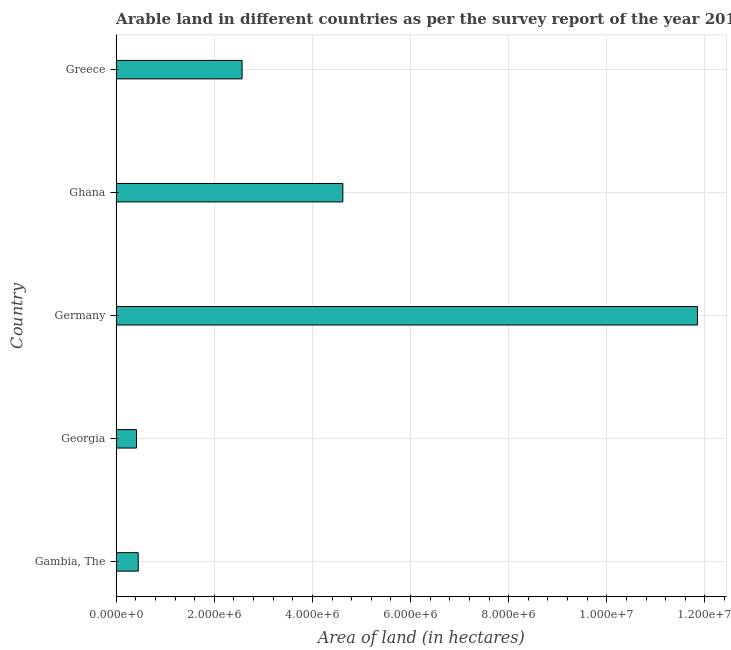Does the graph contain any zero values?
Make the answer very short. No. Does the graph contain grids?
Offer a very short reply. Yes. What is the title of the graph?
Offer a very short reply. Arable land in different countries as per the survey report of the year 2010. What is the label or title of the X-axis?
Provide a succinct answer. Area of land (in hectares). What is the label or title of the Y-axis?
Provide a short and direct response. Country. What is the area of land in Georgia?
Your answer should be very brief. 4.15e+05. Across all countries, what is the maximum area of land?
Offer a terse response. 1.18e+07. Across all countries, what is the minimum area of land?
Give a very brief answer. 4.15e+05. In which country was the area of land maximum?
Offer a terse response. Germany. In which country was the area of land minimum?
Keep it short and to the point. Georgia. What is the sum of the area of land?
Give a very brief answer. 1.99e+07. What is the difference between the area of land in Germany and Greece?
Your answer should be very brief. 9.28e+06. What is the average area of land per country?
Your answer should be compact. 3.98e+06. What is the median area of land?
Give a very brief answer. 2.57e+06. What is the ratio of the area of land in Gambia, The to that in Ghana?
Ensure brevity in your answer.  0.1. Is the area of land in Gambia, The less than that in Ghana?
Provide a succinct answer. Yes. What is the difference between the highest and the second highest area of land?
Keep it short and to the point. 7.23e+06. What is the difference between the highest and the lowest area of land?
Your response must be concise. 1.14e+07. In how many countries, is the area of land greater than the average area of land taken over all countries?
Your response must be concise. 2. What is the difference between two consecutive major ticks on the X-axis?
Your answer should be very brief. 2.00e+06. What is the Area of land (in hectares) in Gambia, The?
Offer a terse response. 4.50e+05. What is the Area of land (in hectares) in Georgia?
Offer a terse response. 4.15e+05. What is the Area of land (in hectares) of Germany?
Provide a short and direct response. 1.18e+07. What is the Area of land (in hectares) of Ghana?
Offer a very short reply. 4.62e+06. What is the Area of land (in hectares) in Greece?
Your answer should be compact. 2.57e+06. What is the difference between the Area of land (in hectares) in Gambia, The and Georgia?
Your answer should be very brief. 3.50e+04. What is the difference between the Area of land (in hectares) in Gambia, The and Germany?
Provide a short and direct response. -1.14e+07. What is the difference between the Area of land (in hectares) in Gambia, The and Ghana?
Your answer should be compact. -4.17e+06. What is the difference between the Area of land (in hectares) in Gambia, The and Greece?
Offer a terse response. -2.12e+06. What is the difference between the Area of land (in hectares) in Georgia and Germany?
Keep it short and to the point. -1.14e+07. What is the difference between the Area of land (in hectares) in Georgia and Ghana?
Your response must be concise. -4.20e+06. What is the difference between the Area of land (in hectares) in Georgia and Greece?
Keep it short and to the point. -2.15e+06. What is the difference between the Area of land (in hectares) in Germany and Ghana?
Ensure brevity in your answer.  7.23e+06. What is the difference between the Area of land (in hectares) in Germany and Greece?
Offer a very short reply. 9.28e+06. What is the difference between the Area of land (in hectares) in Ghana and Greece?
Offer a very short reply. 2.05e+06. What is the ratio of the Area of land (in hectares) in Gambia, The to that in Georgia?
Give a very brief answer. 1.08. What is the ratio of the Area of land (in hectares) in Gambia, The to that in Germany?
Offer a terse response. 0.04. What is the ratio of the Area of land (in hectares) in Gambia, The to that in Ghana?
Give a very brief answer. 0.1. What is the ratio of the Area of land (in hectares) in Gambia, The to that in Greece?
Keep it short and to the point. 0.17. What is the ratio of the Area of land (in hectares) in Georgia to that in Germany?
Provide a short and direct response. 0.04. What is the ratio of the Area of land (in hectares) in Georgia to that in Ghana?
Provide a short and direct response. 0.09. What is the ratio of the Area of land (in hectares) in Georgia to that in Greece?
Offer a very short reply. 0.16. What is the ratio of the Area of land (in hectares) in Germany to that in Ghana?
Offer a terse response. 2.56. What is the ratio of the Area of land (in hectares) in Germany to that in Greece?
Keep it short and to the point. 4.62. What is the ratio of the Area of land (in hectares) in Ghana to that in Greece?
Make the answer very short. 1.8. 